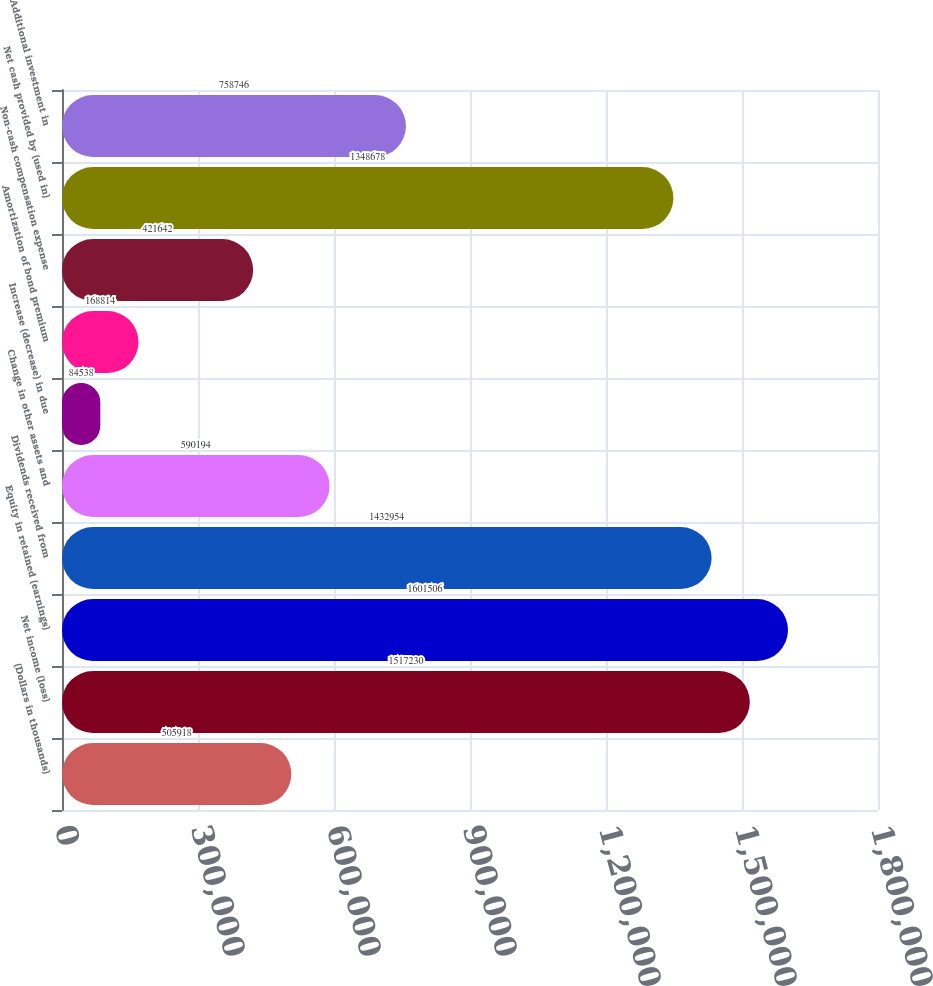Convert chart to OTSL. <chart><loc_0><loc_0><loc_500><loc_500><bar_chart><fcel>(Dollars in thousands)<fcel>Net income (loss)<fcel>Equity in retained (earnings)<fcel>Dividends received from<fcel>Change in other assets and<fcel>Increase (decrease) in due<fcel>Amortization of bond premium<fcel>Non-cash compensation expense<fcel>Net cash provided by (used in)<fcel>Additional investment in<nl><fcel>505918<fcel>1.51723e+06<fcel>1.60151e+06<fcel>1.43295e+06<fcel>590194<fcel>84538<fcel>168814<fcel>421642<fcel>1.34868e+06<fcel>758746<nl></chart> 